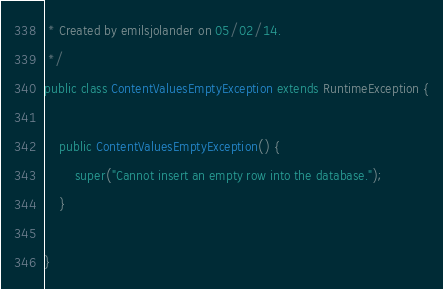<code> <loc_0><loc_0><loc_500><loc_500><_Java_> * Created by emilsjolander on 05/02/14.
 */
public class ContentValuesEmptyException extends RuntimeException {

    public ContentValuesEmptyException() {
        super("Cannot insert an empty row into the database.");
    }

}</code> 